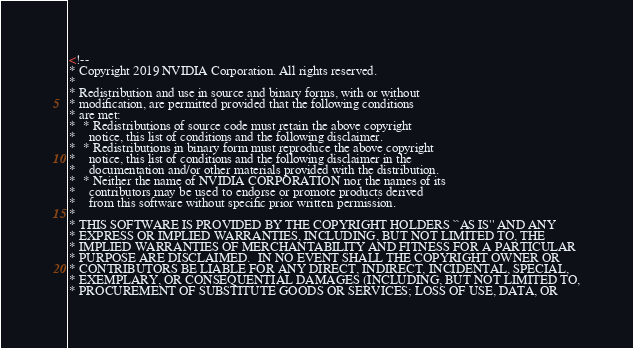<code> <loc_0><loc_0><loc_500><loc_500><_XML_><!--
* Copyright 2019 NVIDIA Corporation. All rights reserved.
*
* Redistribution and use in source and binary forms, with or without
* modification, are permitted provided that the following conditions
* are met:
*  * Redistributions of source code must retain the above copyright
*    notice, this list of conditions and the following disclaimer.
*  * Redistributions in binary form must reproduce the above copyright
*    notice, this list of conditions and the following disclaimer in the
*    documentation and/or other materials provided with the distribution.
*  * Neither the name of NVIDIA CORPORATION nor the names of its
*    contributors may be used to endorse or promote products derived
*    from this software without specific prior written permission.
*
* THIS SOFTWARE IS PROVIDED BY THE COPYRIGHT HOLDERS ``AS IS'' AND ANY
* EXPRESS OR IMPLIED WARRANTIES, INCLUDING, BUT NOT LIMITED TO, THE
* IMPLIED WARRANTIES OF MERCHANTABILITY AND FITNESS FOR A PARTICULAR
* PURPOSE ARE DISCLAIMED.  IN NO EVENT SHALL THE COPYRIGHT OWNER OR
* CONTRIBUTORS BE LIABLE FOR ANY DIRECT, INDIRECT, INCIDENTAL, SPECIAL,
* EXEMPLARY, OR CONSEQUENTIAL DAMAGES (INCLUDING, BUT NOT LIMITED TO,
* PROCUREMENT OF SUBSTITUTE GOODS OR SERVICES; LOSS OF USE, DATA, OR</code> 